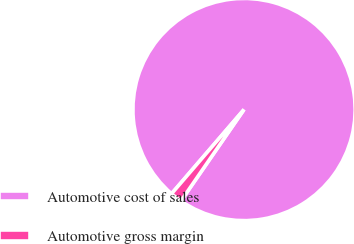Convert chart. <chart><loc_0><loc_0><loc_500><loc_500><pie_chart><fcel>Automotive cost of sales<fcel>Automotive gross margin<nl><fcel>98.3%<fcel>1.7%<nl></chart> 